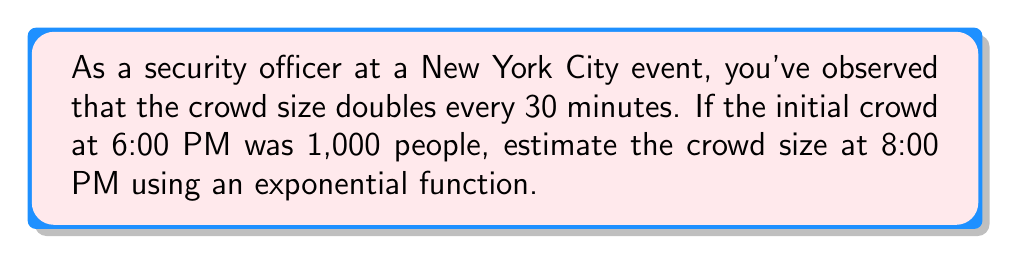What is the answer to this math problem? Let's approach this step-by-step:

1) First, we need to identify the components of our exponential function:
   - Initial value (a): 1,000 people
   - Growth factor (r): 2 (doubles every 30 minutes)
   - Time (t): 2 hours (from 6:00 PM to 8:00 PM)

2) The general form of an exponential function is:
   $$ P(t) = a \cdot r^t $$
   Where P(t) is the population at time t, a is the initial value, r is the growth factor, and t is the time.

3) However, our growth factor is per 30 minutes, while our time is in hours. We need to adjust for this:
   - In 1 hour, the population doubles twice (2^2)
   - So, in t hours, it will be (2^2)^t = 2^(2t)

4) Now we can write our specific function:
   $$ P(t) = 1000 \cdot 2^{2t} $$

5) We want to find P(2), so let's substitute t = 2:
   $$ P(2) = 1000 \cdot 2^{2(2)} = 1000 \cdot 2^4 = 1000 \cdot 16 = 16,000 $$

Therefore, the estimated crowd size at 8:00 PM will be 16,000 people.
Answer: 16,000 people 